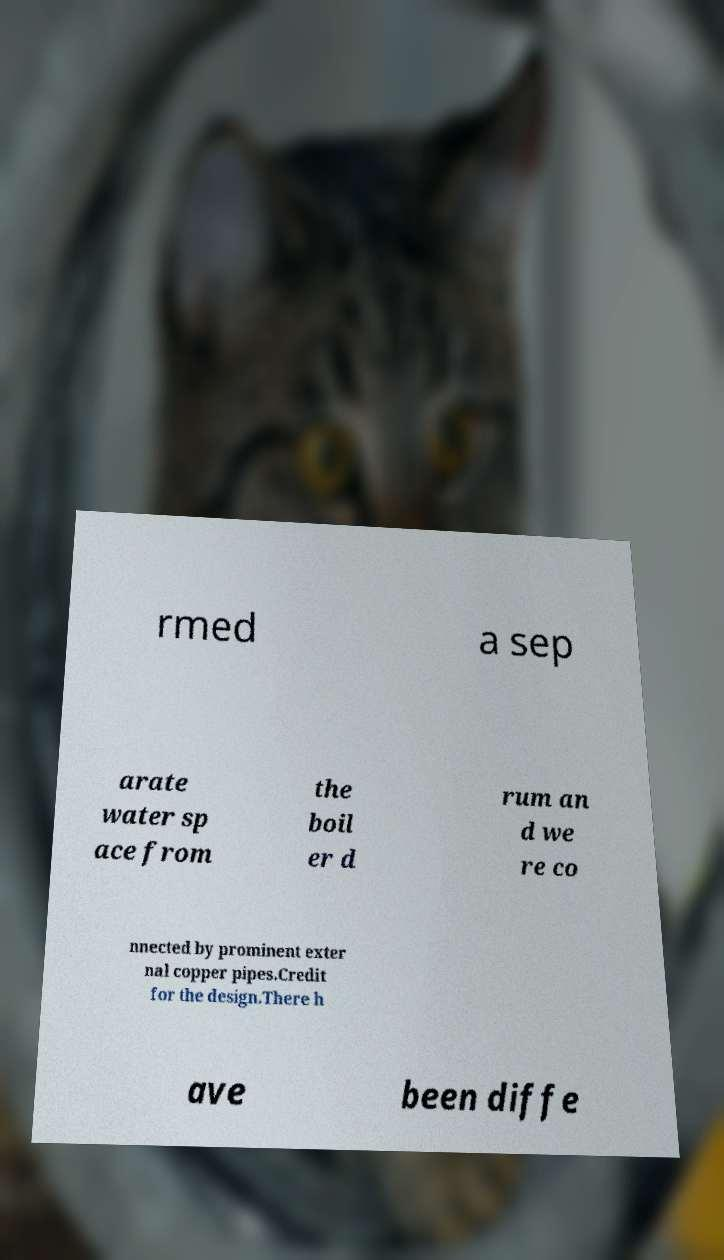What messages or text are displayed in this image? I need them in a readable, typed format. rmed a sep arate water sp ace from the boil er d rum an d we re co nnected by prominent exter nal copper pipes.Credit for the design.There h ave been diffe 